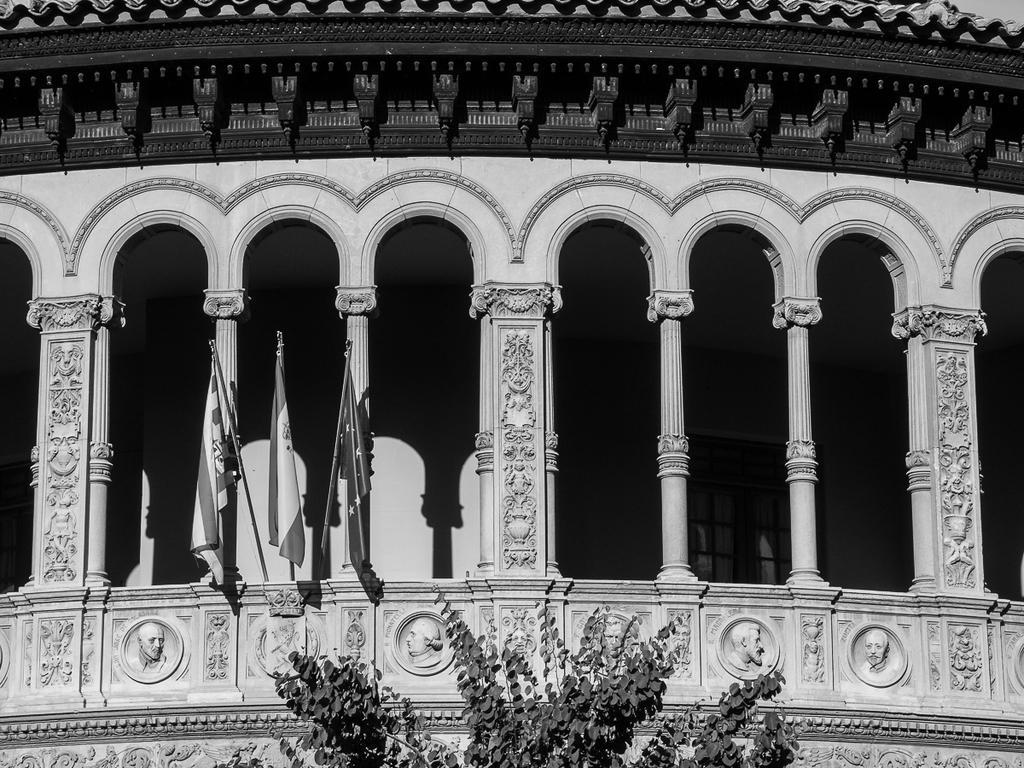How would you summarize this image in a sentence or two? This is a black and white image. At the bottom of the image, there is a tree having leaves. In the background, there are three flags attached to a wall of the building which is having pillars and sculptures on the wall. 